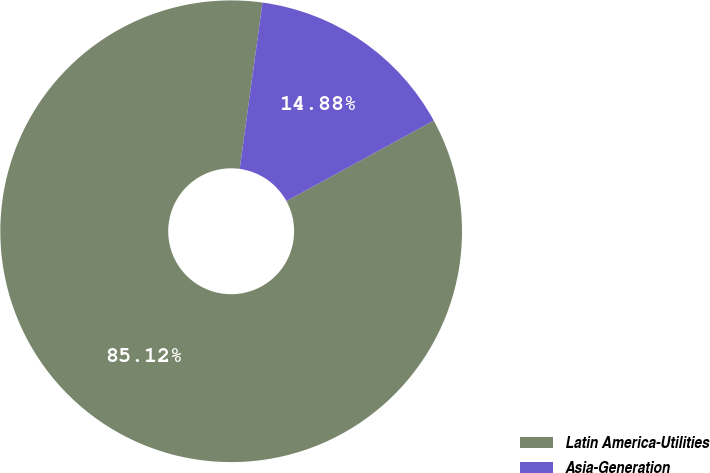Convert chart. <chart><loc_0><loc_0><loc_500><loc_500><pie_chart><fcel>Latin America-Utilities<fcel>Asia-Generation<nl><fcel>85.12%<fcel>14.88%<nl></chart> 